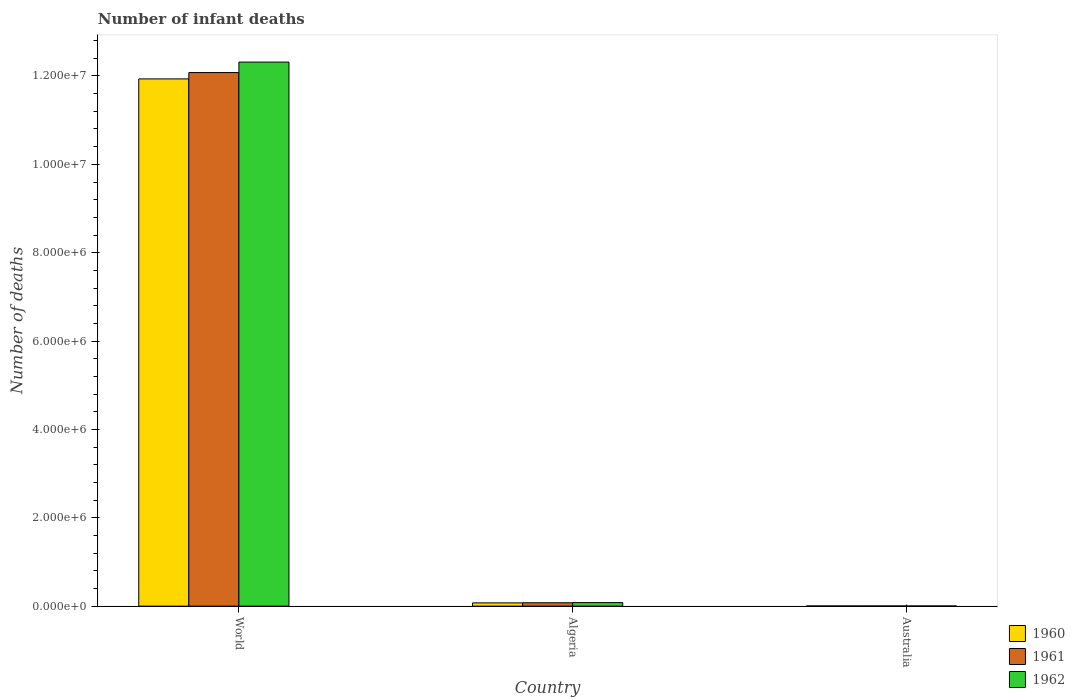How many groups of bars are there?
Your answer should be compact. 3. Are the number of bars per tick equal to the number of legend labels?
Offer a very short reply. Yes. Are the number of bars on each tick of the X-axis equal?
Offer a terse response. Yes. What is the number of infant deaths in 1962 in World?
Your answer should be very brief. 1.23e+07. Across all countries, what is the maximum number of infant deaths in 1961?
Offer a very short reply. 1.21e+07. Across all countries, what is the minimum number of infant deaths in 1960?
Ensure brevity in your answer.  4758. What is the total number of infant deaths in 1962 in the graph?
Provide a succinct answer. 1.24e+07. What is the difference between the number of infant deaths in 1961 in Algeria and that in World?
Your answer should be very brief. -1.20e+07. What is the difference between the number of infant deaths in 1961 in World and the number of infant deaths in 1960 in Australia?
Your response must be concise. 1.21e+07. What is the average number of infant deaths in 1962 per country?
Offer a very short reply. 4.13e+06. What is the difference between the number of infant deaths of/in 1961 and number of infant deaths of/in 1962 in Australia?
Keep it short and to the point. 122. In how many countries, is the number of infant deaths in 1960 greater than 2400000?
Offer a terse response. 1. What is the ratio of the number of infant deaths in 1962 in Australia to that in World?
Ensure brevity in your answer.  0. What is the difference between the highest and the second highest number of infant deaths in 1960?
Offer a very short reply. 1.19e+07. What is the difference between the highest and the lowest number of infant deaths in 1962?
Provide a short and direct response. 1.23e+07. Is it the case that in every country, the sum of the number of infant deaths in 1961 and number of infant deaths in 1960 is greater than the number of infant deaths in 1962?
Your answer should be very brief. Yes. Are all the bars in the graph horizontal?
Provide a succinct answer. No. Does the graph contain any zero values?
Give a very brief answer. No. Where does the legend appear in the graph?
Provide a short and direct response. Bottom right. How many legend labels are there?
Keep it short and to the point. 3. What is the title of the graph?
Your answer should be very brief. Number of infant deaths. What is the label or title of the Y-axis?
Ensure brevity in your answer.  Number of deaths. What is the Number of deaths of 1960 in World?
Keep it short and to the point. 1.19e+07. What is the Number of deaths in 1961 in World?
Give a very brief answer. 1.21e+07. What is the Number of deaths in 1962 in World?
Make the answer very short. 1.23e+07. What is the Number of deaths in 1960 in Algeria?
Offer a terse response. 7.45e+04. What is the Number of deaths of 1961 in Algeria?
Keep it short and to the point. 7.68e+04. What is the Number of deaths in 1962 in Algeria?
Your answer should be very brief. 8.05e+04. What is the Number of deaths in 1960 in Australia?
Your answer should be very brief. 4758. What is the Number of deaths of 1961 in Australia?
Offer a very short reply. 4745. What is the Number of deaths of 1962 in Australia?
Offer a terse response. 4623. Across all countries, what is the maximum Number of deaths in 1960?
Provide a short and direct response. 1.19e+07. Across all countries, what is the maximum Number of deaths of 1961?
Ensure brevity in your answer.  1.21e+07. Across all countries, what is the maximum Number of deaths in 1962?
Your answer should be compact. 1.23e+07. Across all countries, what is the minimum Number of deaths of 1960?
Your answer should be compact. 4758. Across all countries, what is the minimum Number of deaths in 1961?
Offer a very short reply. 4745. Across all countries, what is the minimum Number of deaths of 1962?
Give a very brief answer. 4623. What is the total Number of deaths in 1960 in the graph?
Keep it short and to the point. 1.20e+07. What is the total Number of deaths in 1961 in the graph?
Your response must be concise. 1.22e+07. What is the total Number of deaths in 1962 in the graph?
Offer a very short reply. 1.24e+07. What is the difference between the Number of deaths of 1960 in World and that in Algeria?
Keep it short and to the point. 1.19e+07. What is the difference between the Number of deaths in 1961 in World and that in Algeria?
Provide a succinct answer. 1.20e+07. What is the difference between the Number of deaths in 1962 in World and that in Algeria?
Your answer should be compact. 1.22e+07. What is the difference between the Number of deaths of 1960 in World and that in Australia?
Ensure brevity in your answer.  1.19e+07. What is the difference between the Number of deaths in 1961 in World and that in Australia?
Ensure brevity in your answer.  1.21e+07. What is the difference between the Number of deaths of 1962 in World and that in Australia?
Keep it short and to the point. 1.23e+07. What is the difference between the Number of deaths in 1960 in Algeria and that in Australia?
Offer a very short reply. 6.98e+04. What is the difference between the Number of deaths of 1961 in Algeria and that in Australia?
Your answer should be very brief. 7.20e+04. What is the difference between the Number of deaths of 1962 in Algeria and that in Australia?
Your response must be concise. 7.58e+04. What is the difference between the Number of deaths of 1960 in World and the Number of deaths of 1961 in Algeria?
Keep it short and to the point. 1.19e+07. What is the difference between the Number of deaths of 1960 in World and the Number of deaths of 1962 in Algeria?
Offer a very short reply. 1.19e+07. What is the difference between the Number of deaths of 1961 in World and the Number of deaths of 1962 in Algeria?
Offer a very short reply. 1.20e+07. What is the difference between the Number of deaths in 1960 in World and the Number of deaths in 1961 in Australia?
Your answer should be very brief. 1.19e+07. What is the difference between the Number of deaths in 1960 in World and the Number of deaths in 1962 in Australia?
Offer a terse response. 1.19e+07. What is the difference between the Number of deaths of 1961 in World and the Number of deaths of 1962 in Australia?
Provide a succinct answer. 1.21e+07. What is the difference between the Number of deaths of 1960 in Algeria and the Number of deaths of 1961 in Australia?
Offer a terse response. 6.98e+04. What is the difference between the Number of deaths in 1960 in Algeria and the Number of deaths in 1962 in Australia?
Your answer should be compact. 6.99e+04. What is the difference between the Number of deaths in 1961 in Algeria and the Number of deaths in 1962 in Australia?
Keep it short and to the point. 7.22e+04. What is the average Number of deaths of 1960 per country?
Ensure brevity in your answer.  4.00e+06. What is the average Number of deaths of 1961 per country?
Ensure brevity in your answer.  4.05e+06. What is the average Number of deaths of 1962 per country?
Ensure brevity in your answer.  4.13e+06. What is the difference between the Number of deaths of 1960 and Number of deaths of 1961 in World?
Ensure brevity in your answer.  -1.43e+05. What is the difference between the Number of deaths in 1960 and Number of deaths in 1962 in World?
Give a very brief answer. -3.81e+05. What is the difference between the Number of deaths of 1961 and Number of deaths of 1962 in World?
Offer a very short reply. -2.37e+05. What is the difference between the Number of deaths in 1960 and Number of deaths in 1961 in Algeria?
Keep it short and to the point. -2242. What is the difference between the Number of deaths in 1960 and Number of deaths in 1962 in Algeria?
Ensure brevity in your answer.  -5926. What is the difference between the Number of deaths of 1961 and Number of deaths of 1962 in Algeria?
Make the answer very short. -3684. What is the difference between the Number of deaths of 1960 and Number of deaths of 1962 in Australia?
Offer a terse response. 135. What is the difference between the Number of deaths of 1961 and Number of deaths of 1962 in Australia?
Offer a very short reply. 122. What is the ratio of the Number of deaths in 1960 in World to that in Algeria?
Ensure brevity in your answer.  160.08. What is the ratio of the Number of deaths in 1961 in World to that in Algeria?
Your answer should be compact. 157.27. What is the ratio of the Number of deaths of 1962 in World to that in Algeria?
Offer a very short reply. 153.02. What is the ratio of the Number of deaths of 1960 in World to that in Australia?
Your answer should be compact. 2508.11. What is the ratio of the Number of deaths in 1961 in World to that in Australia?
Your answer should be compact. 2545.14. What is the ratio of the Number of deaths of 1962 in World to that in Australia?
Offer a terse response. 2663.68. What is the ratio of the Number of deaths in 1960 in Algeria to that in Australia?
Your response must be concise. 15.67. What is the ratio of the Number of deaths in 1961 in Algeria to that in Australia?
Make the answer very short. 16.18. What is the ratio of the Number of deaths in 1962 in Algeria to that in Australia?
Your answer should be compact. 17.41. What is the difference between the highest and the second highest Number of deaths of 1960?
Your answer should be very brief. 1.19e+07. What is the difference between the highest and the second highest Number of deaths in 1961?
Your answer should be compact. 1.20e+07. What is the difference between the highest and the second highest Number of deaths of 1962?
Keep it short and to the point. 1.22e+07. What is the difference between the highest and the lowest Number of deaths of 1960?
Provide a short and direct response. 1.19e+07. What is the difference between the highest and the lowest Number of deaths of 1961?
Your answer should be compact. 1.21e+07. What is the difference between the highest and the lowest Number of deaths in 1962?
Offer a very short reply. 1.23e+07. 